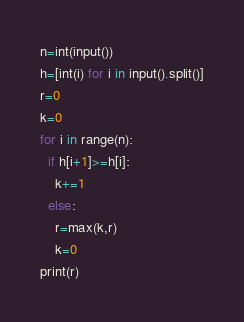<code> <loc_0><loc_0><loc_500><loc_500><_Python_>n=int(input())
h=[int(i) for i in input().split()]
r=0
k=0
for i in range(n):
  if h[i+1]>=h[i]:
    k+=1
  else:
    r=max(k,r)
    k=0
print(r)</code> 